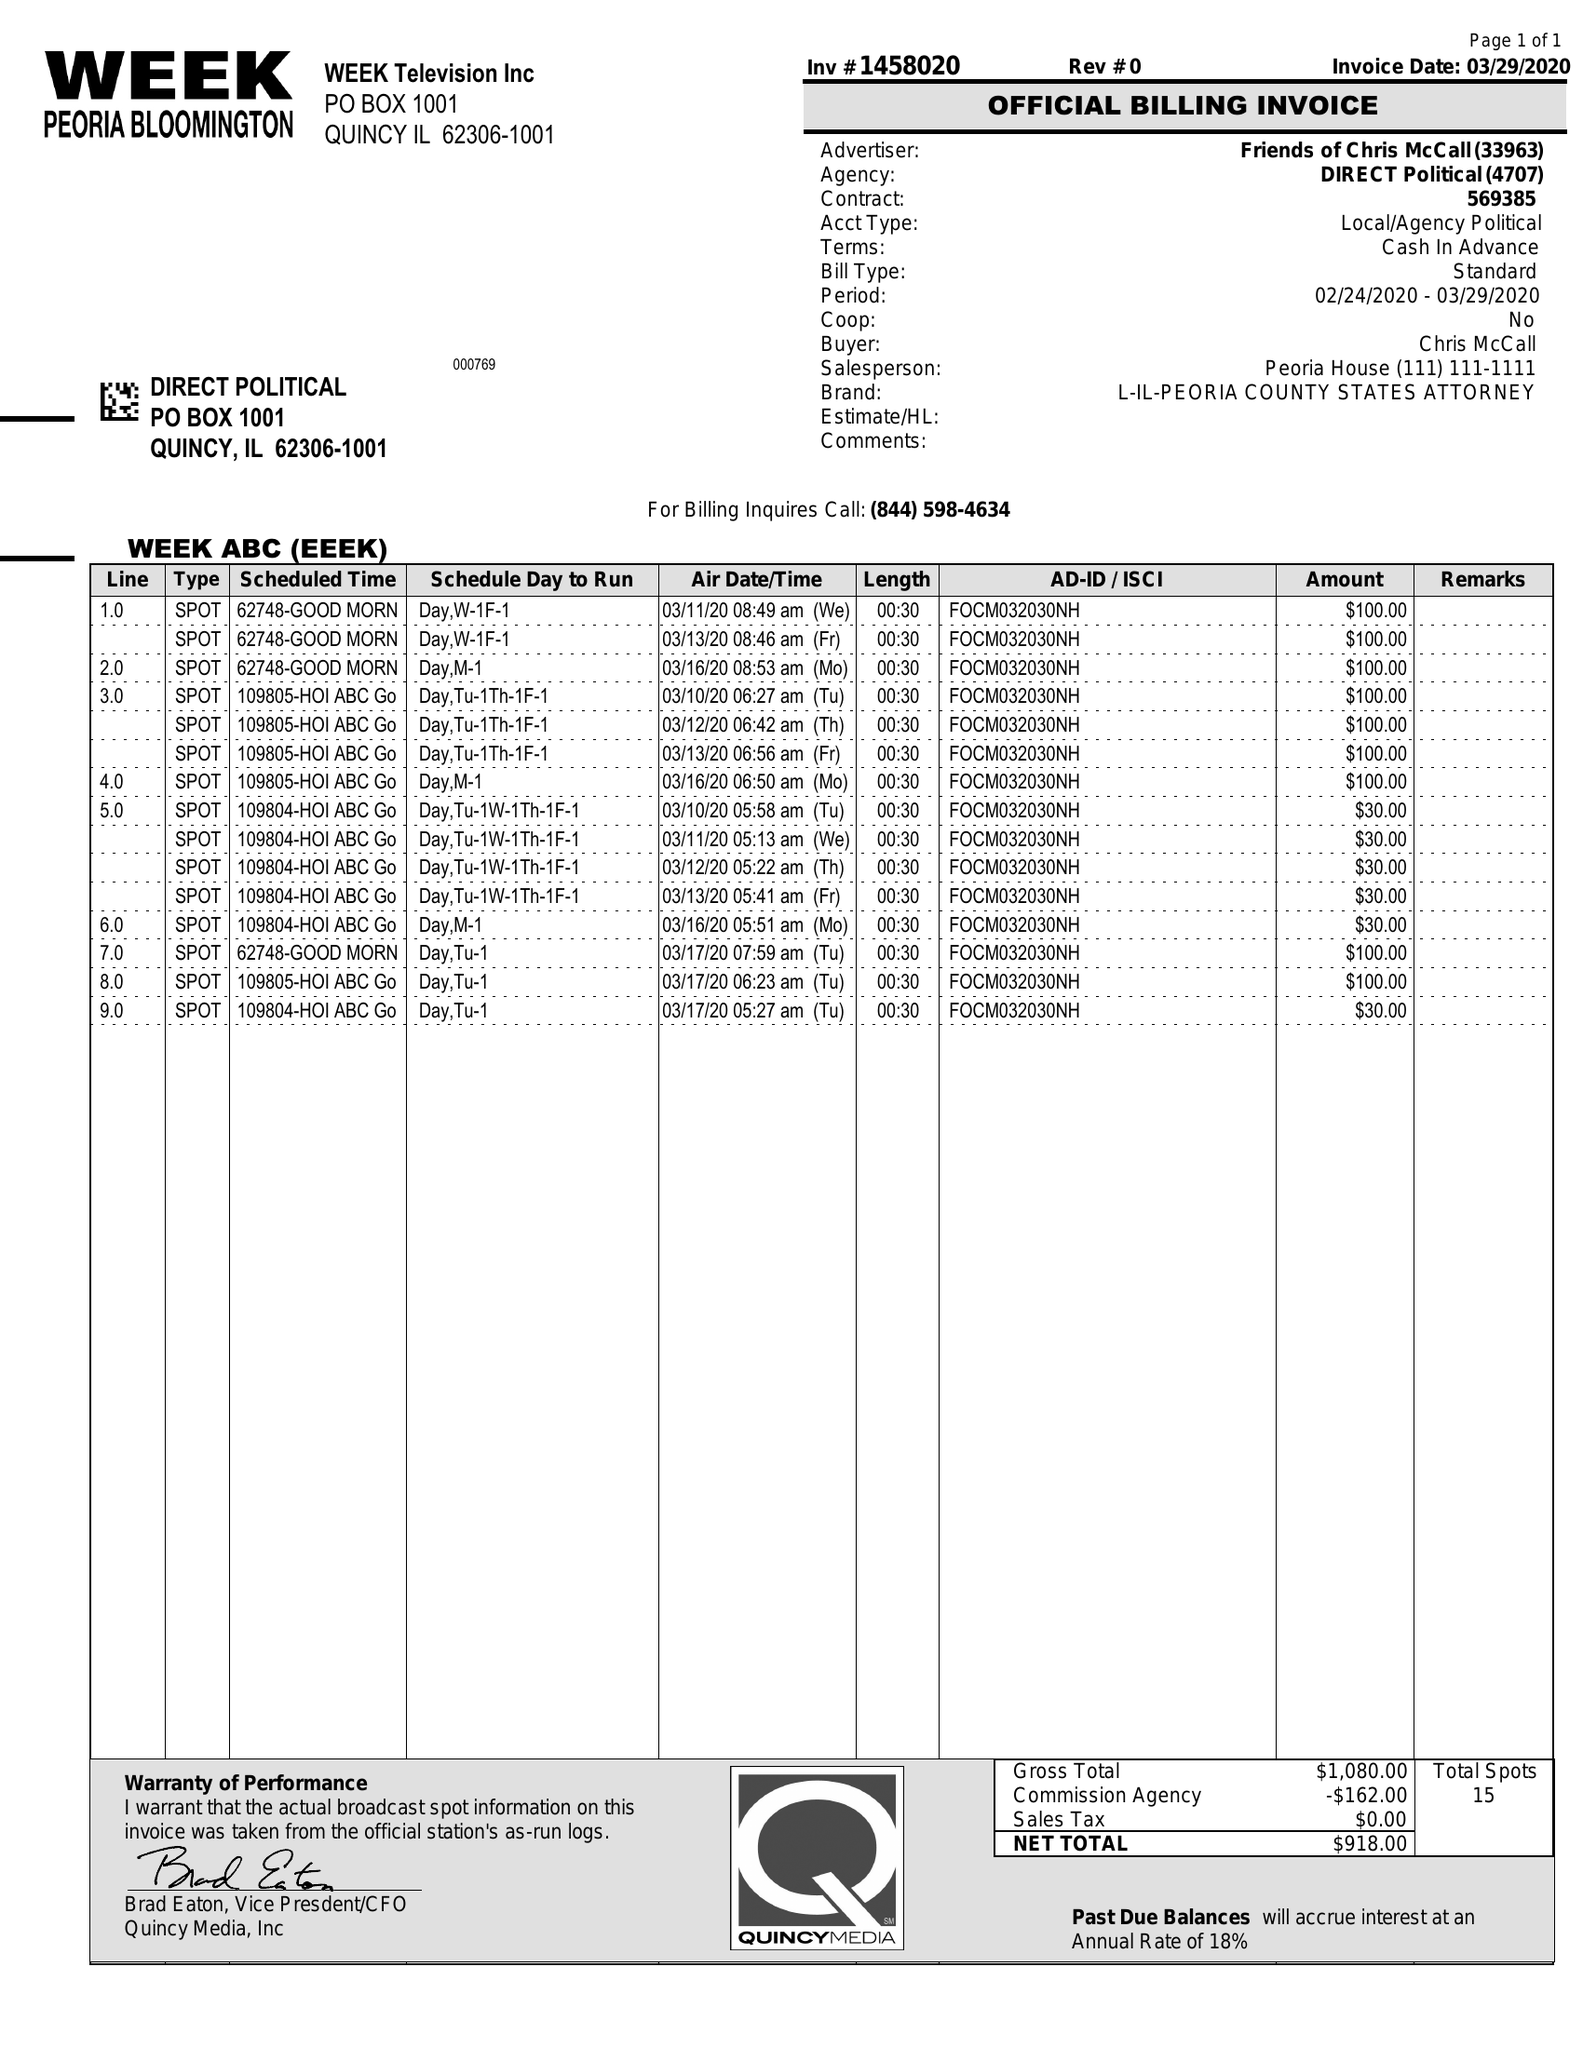What is the value for the flight_from?
Answer the question using a single word or phrase. 03/10/20 